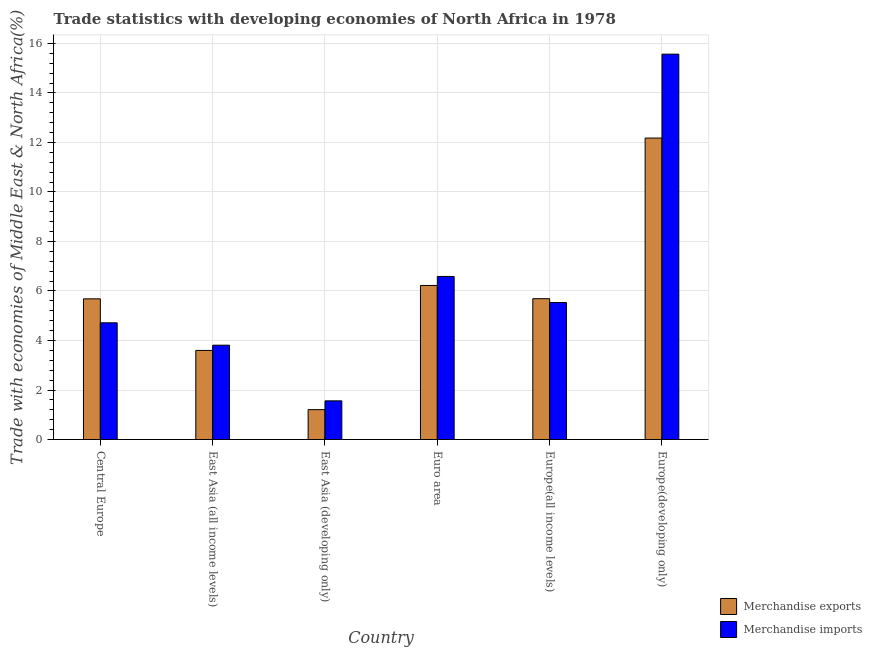Are the number of bars per tick equal to the number of legend labels?
Ensure brevity in your answer.  Yes. Are the number of bars on each tick of the X-axis equal?
Your response must be concise. Yes. What is the label of the 2nd group of bars from the left?
Keep it short and to the point. East Asia (all income levels). In how many cases, is the number of bars for a given country not equal to the number of legend labels?
Keep it short and to the point. 0. What is the merchandise exports in Europe(developing only)?
Your answer should be compact. 12.18. Across all countries, what is the maximum merchandise imports?
Provide a short and direct response. 15.57. Across all countries, what is the minimum merchandise imports?
Provide a short and direct response. 1.56. In which country was the merchandise exports maximum?
Ensure brevity in your answer.  Europe(developing only). In which country was the merchandise exports minimum?
Provide a succinct answer. East Asia (developing only). What is the total merchandise imports in the graph?
Make the answer very short. 37.78. What is the difference between the merchandise imports in East Asia (developing only) and that in Europe(developing only)?
Give a very brief answer. -14.01. What is the difference between the merchandise exports in Central Europe and the merchandise imports in Europe(developing only)?
Ensure brevity in your answer.  -9.89. What is the average merchandise exports per country?
Ensure brevity in your answer.  5.76. What is the difference between the merchandise exports and merchandise imports in East Asia (developing only)?
Offer a terse response. -0.35. In how many countries, is the merchandise imports greater than 0.8 %?
Your answer should be very brief. 6. What is the ratio of the merchandise imports in East Asia (developing only) to that in Euro area?
Your answer should be very brief. 0.24. Is the difference between the merchandise exports in Euro area and Europe(developing only) greater than the difference between the merchandise imports in Euro area and Europe(developing only)?
Provide a succinct answer. Yes. What is the difference between the highest and the second highest merchandise imports?
Your answer should be compact. 8.98. What is the difference between the highest and the lowest merchandise imports?
Your answer should be compact. 14.01. What does the 2nd bar from the right in East Asia (developing only) represents?
Offer a very short reply. Merchandise exports. How many bars are there?
Provide a short and direct response. 12. What is the difference between two consecutive major ticks on the Y-axis?
Keep it short and to the point. 2. Does the graph contain any zero values?
Your response must be concise. No. Where does the legend appear in the graph?
Provide a succinct answer. Bottom right. How many legend labels are there?
Keep it short and to the point. 2. How are the legend labels stacked?
Give a very brief answer. Vertical. What is the title of the graph?
Your answer should be compact. Trade statistics with developing economies of North Africa in 1978. What is the label or title of the Y-axis?
Give a very brief answer. Trade with economies of Middle East & North Africa(%). What is the Trade with economies of Middle East & North Africa(%) in Merchandise exports in Central Europe?
Your response must be concise. 5.68. What is the Trade with economies of Middle East & North Africa(%) of Merchandise imports in Central Europe?
Give a very brief answer. 4.71. What is the Trade with economies of Middle East & North Africa(%) in Merchandise exports in East Asia (all income levels)?
Keep it short and to the point. 3.6. What is the Trade with economies of Middle East & North Africa(%) in Merchandise imports in East Asia (all income levels)?
Offer a terse response. 3.81. What is the Trade with economies of Middle East & North Africa(%) of Merchandise exports in East Asia (developing only)?
Make the answer very short. 1.21. What is the Trade with economies of Middle East & North Africa(%) in Merchandise imports in East Asia (developing only)?
Your response must be concise. 1.56. What is the Trade with economies of Middle East & North Africa(%) of Merchandise exports in Euro area?
Provide a succinct answer. 6.22. What is the Trade with economies of Middle East & North Africa(%) in Merchandise imports in Euro area?
Provide a succinct answer. 6.59. What is the Trade with economies of Middle East & North Africa(%) of Merchandise exports in Europe(all income levels)?
Make the answer very short. 5.69. What is the Trade with economies of Middle East & North Africa(%) in Merchandise imports in Europe(all income levels)?
Offer a terse response. 5.54. What is the Trade with economies of Middle East & North Africa(%) in Merchandise exports in Europe(developing only)?
Give a very brief answer. 12.18. What is the Trade with economies of Middle East & North Africa(%) of Merchandise imports in Europe(developing only)?
Provide a succinct answer. 15.57. Across all countries, what is the maximum Trade with economies of Middle East & North Africa(%) of Merchandise exports?
Your answer should be very brief. 12.18. Across all countries, what is the maximum Trade with economies of Middle East & North Africa(%) in Merchandise imports?
Your response must be concise. 15.57. Across all countries, what is the minimum Trade with economies of Middle East & North Africa(%) of Merchandise exports?
Offer a very short reply. 1.21. Across all countries, what is the minimum Trade with economies of Middle East & North Africa(%) of Merchandise imports?
Provide a short and direct response. 1.56. What is the total Trade with economies of Middle East & North Africa(%) in Merchandise exports in the graph?
Keep it short and to the point. 34.58. What is the total Trade with economies of Middle East & North Africa(%) in Merchandise imports in the graph?
Provide a succinct answer. 37.78. What is the difference between the Trade with economies of Middle East & North Africa(%) of Merchandise exports in Central Europe and that in East Asia (all income levels)?
Provide a succinct answer. 2.08. What is the difference between the Trade with economies of Middle East & North Africa(%) in Merchandise imports in Central Europe and that in East Asia (all income levels)?
Offer a very short reply. 0.9. What is the difference between the Trade with economies of Middle East & North Africa(%) in Merchandise exports in Central Europe and that in East Asia (developing only)?
Your answer should be compact. 4.48. What is the difference between the Trade with economies of Middle East & North Africa(%) in Merchandise imports in Central Europe and that in East Asia (developing only)?
Make the answer very short. 3.15. What is the difference between the Trade with economies of Middle East & North Africa(%) of Merchandise exports in Central Europe and that in Euro area?
Offer a very short reply. -0.54. What is the difference between the Trade with economies of Middle East & North Africa(%) in Merchandise imports in Central Europe and that in Euro area?
Offer a very short reply. -1.87. What is the difference between the Trade with economies of Middle East & North Africa(%) of Merchandise exports in Central Europe and that in Europe(all income levels)?
Give a very brief answer. -0.01. What is the difference between the Trade with economies of Middle East & North Africa(%) of Merchandise imports in Central Europe and that in Europe(all income levels)?
Provide a short and direct response. -0.82. What is the difference between the Trade with economies of Middle East & North Africa(%) of Merchandise exports in Central Europe and that in Europe(developing only)?
Give a very brief answer. -6.5. What is the difference between the Trade with economies of Middle East & North Africa(%) of Merchandise imports in Central Europe and that in Europe(developing only)?
Offer a terse response. -10.85. What is the difference between the Trade with economies of Middle East & North Africa(%) of Merchandise exports in East Asia (all income levels) and that in East Asia (developing only)?
Your response must be concise. 2.39. What is the difference between the Trade with economies of Middle East & North Africa(%) in Merchandise imports in East Asia (all income levels) and that in East Asia (developing only)?
Offer a very short reply. 2.25. What is the difference between the Trade with economies of Middle East & North Africa(%) of Merchandise exports in East Asia (all income levels) and that in Euro area?
Give a very brief answer. -2.62. What is the difference between the Trade with economies of Middle East & North Africa(%) of Merchandise imports in East Asia (all income levels) and that in Euro area?
Keep it short and to the point. -2.78. What is the difference between the Trade with economies of Middle East & North Africa(%) in Merchandise exports in East Asia (all income levels) and that in Europe(all income levels)?
Make the answer very short. -2.09. What is the difference between the Trade with economies of Middle East & North Africa(%) in Merchandise imports in East Asia (all income levels) and that in Europe(all income levels)?
Offer a very short reply. -1.73. What is the difference between the Trade with economies of Middle East & North Africa(%) of Merchandise exports in East Asia (all income levels) and that in Europe(developing only)?
Provide a short and direct response. -8.58. What is the difference between the Trade with economies of Middle East & North Africa(%) in Merchandise imports in East Asia (all income levels) and that in Europe(developing only)?
Ensure brevity in your answer.  -11.76. What is the difference between the Trade with economies of Middle East & North Africa(%) of Merchandise exports in East Asia (developing only) and that in Euro area?
Your response must be concise. -5.02. What is the difference between the Trade with economies of Middle East & North Africa(%) in Merchandise imports in East Asia (developing only) and that in Euro area?
Give a very brief answer. -5.03. What is the difference between the Trade with economies of Middle East & North Africa(%) in Merchandise exports in East Asia (developing only) and that in Europe(all income levels)?
Provide a succinct answer. -4.48. What is the difference between the Trade with economies of Middle East & North Africa(%) in Merchandise imports in East Asia (developing only) and that in Europe(all income levels)?
Keep it short and to the point. -3.97. What is the difference between the Trade with economies of Middle East & North Africa(%) in Merchandise exports in East Asia (developing only) and that in Europe(developing only)?
Provide a succinct answer. -10.97. What is the difference between the Trade with economies of Middle East & North Africa(%) in Merchandise imports in East Asia (developing only) and that in Europe(developing only)?
Your response must be concise. -14.01. What is the difference between the Trade with economies of Middle East & North Africa(%) of Merchandise exports in Euro area and that in Europe(all income levels)?
Provide a short and direct response. 0.53. What is the difference between the Trade with economies of Middle East & North Africa(%) in Merchandise imports in Euro area and that in Europe(all income levels)?
Provide a short and direct response. 1.05. What is the difference between the Trade with economies of Middle East & North Africa(%) in Merchandise exports in Euro area and that in Europe(developing only)?
Your answer should be compact. -5.96. What is the difference between the Trade with economies of Middle East & North Africa(%) of Merchandise imports in Euro area and that in Europe(developing only)?
Ensure brevity in your answer.  -8.98. What is the difference between the Trade with economies of Middle East & North Africa(%) in Merchandise exports in Europe(all income levels) and that in Europe(developing only)?
Your response must be concise. -6.49. What is the difference between the Trade with economies of Middle East & North Africa(%) in Merchandise imports in Europe(all income levels) and that in Europe(developing only)?
Offer a terse response. -10.03. What is the difference between the Trade with economies of Middle East & North Africa(%) in Merchandise exports in Central Europe and the Trade with economies of Middle East & North Africa(%) in Merchandise imports in East Asia (all income levels)?
Offer a terse response. 1.87. What is the difference between the Trade with economies of Middle East & North Africa(%) of Merchandise exports in Central Europe and the Trade with economies of Middle East & North Africa(%) of Merchandise imports in East Asia (developing only)?
Offer a very short reply. 4.12. What is the difference between the Trade with economies of Middle East & North Africa(%) in Merchandise exports in Central Europe and the Trade with economies of Middle East & North Africa(%) in Merchandise imports in Euro area?
Give a very brief answer. -0.9. What is the difference between the Trade with economies of Middle East & North Africa(%) of Merchandise exports in Central Europe and the Trade with economies of Middle East & North Africa(%) of Merchandise imports in Europe(all income levels)?
Keep it short and to the point. 0.15. What is the difference between the Trade with economies of Middle East & North Africa(%) in Merchandise exports in Central Europe and the Trade with economies of Middle East & North Africa(%) in Merchandise imports in Europe(developing only)?
Your answer should be very brief. -9.89. What is the difference between the Trade with economies of Middle East & North Africa(%) of Merchandise exports in East Asia (all income levels) and the Trade with economies of Middle East & North Africa(%) of Merchandise imports in East Asia (developing only)?
Provide a succinct answer. 2.04. What is the difference between the Trade with economies of Middle East & North Africa(%) in Merchandise exports in East Asia (all income levels) and the Trade with economies of Middle East & North Africa(%) in Merchandise imports in Euro area?
Give a very brief answer. -2.99. What is the difference between the Trade with economies of Middle East & North Africa(%) in Merchandise exports in East Asia (all income levels) and the Trade with economies of Middle East & North Africa(%) in Merchandise imports in Europe(all income levels)?
Ensure brevity in your answer.  -1.94. What is the difference between the Trade with economies of Middle East & North Africa(%) of Merchandise exports in East Asia (all income levels) and the Trade with economies of Middle East & North Africa(%) of Merchandise imports in Europe(developing only)?
Keep it short and to the point. -11.97. What is the difference between the Trade with economies of Middle East & North Africa(%) of Merchandise exports in East Asia (developing only) and the Trade with economies of Middle East & North Africa(%) of Merchandise imports in Euro area?
Offer a terse response. -5.38. What is the difference between the Trade with economies of Middle East & North Africa(%) in Merchandise exports in East Asia (developing only) and the Trade with economies of Middle East & North Africa(%) in Merchandise imports in Europe(all income levels)?
Your answer should be very brief. -4.33. What is the difference between the Trade with economies of Middle East & North Africa(%) in Merchandise exports in East Asia (developing only) and the Trade with economies of Middle East & North Africa(%) in Merchandise imports in Europe(developing only)?
Ensure brevity in your answer.  -14.36. What is the difference between the Trade with economies of Middle East & North Africa(%) in Merchandise exports in Euro area and the Trade with economies of Middle East & North Africa(%) in Merchandise imports in Europe(all income levels)?
Make the answer very short. 0.69. What is the difference between the Trade with economies of Middle East & North Africa(%) in Merchandise exports in Euro area and the Trade with economies of Middle East & North Africa(%) in Merchandise imports in Europe(developing only)?
Offer a very short reply. -9.34. What is the difference between the Trade with economies of Middle East & North Africa(%) of Merchandise exports in Europe(all income levels) and the Trade with economies of Middle East & North Africa(%) of Merchandise imports in Europe(developing only)?
Keep it short and to the point. -9.88. What is the average Trade with economies of Middle East & North Africa(%) of Merchandise exports per country?
Give a very brief answer. 5.76. What is the average Trade with economies of Middle East & North Africa(%) in Merchandise imports per country?
Your answer should be compact. 6.3. What is the difference between the Trade with economies of Middle East & North Africa(%) of Merchandise exports and Trade with economies of Middle East & North Africa(%) of Merchandise imports in Central Europe?
Make the answer very short. 0.97. What is the difference between the Trade with economies of Middle East & North Africa(%) in Merchandise exports and Trade with economies of Middle East & North Africa(%) in Merchandise imports in East Asia (all income levels)?
Give a very brief answer. -0.21. What is the difference between the Trade with economies of Middle East & North Africa(%) of Merchandise exports and Trade with economies of Middle East & North Africa(%) of Merchandise imports in East Asia (developing only)?
Provide a succinct answer. -0.35. What is the difference between the Trade with economies of Middle East & North Africa(%) in Merchandise exports and Trade with economies of Middle East & North Africa(%) in Merchandise imports in Euro area?
Offer a terse response. -0.36. What is the difference between the Trade with economies of Middle East & North Africa(%) of Merchandise exports and Trade with economies of Middle East & North Africa(%) of Merchandise imports in Europe(all income levels)?
Offer a terse response. 0.15. What is the difference between the Trade with economies of Middle East & North Africa(%) of Merchandise exports and Trade with economies of Middle East & North Africa(%) of Merchandise imports in Europe(developing only)?
Offer a very short reply. -3.39. What is the ratio of the Trade with economies of Middle East & North Africa(%) in Merchandise exports in Central Europe to that in East Asia (all income levels)?
Give a very brief answer. 1.58. What is the ratio of the Trade with economies of Middle East & North Africa(%) of Merchandise imports in Central Europe to that in East Asia (all income levels)?
Provide a succinct answer. 1.24. What is the ratio of the Trade with economies of Middle East & North Africa(%) of Merchandise exports in Central Europe to that in East Asia (developing only)?
Ensure brevity in your answer.  4.71. What is the ratio of the Trade with economies of Middle East & North Africa(%) of Merchandise imports in Central Europe to that in East Asia (developing only)?
Keep it short and to the point. 3.02. What is the ratio of the Trade with economies of Middle East & North Africa(%) in Merchandise exports in Central Europe to that in Euro area?
Make the answer very short. 0.91. What is the ratio of the Trade with economies of Middle East & North Africa(%) in Merchandise imports in Central Europe to that in Euro area?
Give a very brief answer. 0.72. What is the ratio of the Trade with economies of Middle East & North Africa(%) in Merchandise imports in Central Europe to that in Europe(all income levels)?
Provide a succinct answer. 0.85. What is the ratio of the Trade with economies of Middle East & North Africa(%) in Merchandise exports in Central Europe to that in Europe(developing only)?
Give a very brief answer. 0.47. What is the ratio of the Trade with economies of Middle East & North Africa(%) of Merchandise imports in Central Europe to that in Europe(developing only)?
Keep it short and to the point. 0.3. What is the ratio of the Trade with economies of Middle East & North Africa(%) in Merchandise exports in East Asia (all income levels) to that in East Asia (developing only)?
Your answer should be compact. 2.98. What is the ratio of the Trade with economies of Middle East & North Africa(%) of Merchandise imports in East Asia (all income levels) to that in East Asia (developing only)?
Ensure brevity in your answer.  2.44. What is the ratio of the Trade with economies of Middle East & North Africa(%) of Merchandise exports in East Asia (all income levels) to that in Euro area?
Give a very brief answer. 0.58. What is the ratio of the Trade with economies of Middle East & North Africa(%) in Merchandise imports in East Asia (all income levels) to that in Euro area?
Keep it short and to the point. 0.58. What is the ratio of the Trade with economies of Middle East & North Africa(%) of Merchandise exports in East Asia (all income levels) to that in Europe(all income levels)?
Your answer should be very brief. 0.63. What is the ratio of the Trade with economies of Middle East & North Africa(%) in Merchandise imports in East Asia (all income levels) to that in Europe(all income levels)?
Give a very brief answer. 0.69. What is the ratio of the Trade with economies of Middle East & North Africa(%) of Merchandise exports in East Asia (all income levels) to that in Europe(developing only)?
Your response must be concise. 0.3. What is the ratio of the Trade with economies of Middle East & North Africa(%) of Merchandise imports in East Asia (all income levels) to that in Europe(developing only)?
Give a very brief answer. 0.24. What is the ratio of the Trade with economies of Middle East & North Africa(%) in Merchandise exports in East Asia (developing only) to that in Euro area?
Your answer should be very brief. 0.19. What is the ratio of the Trade with economies of Middle East & North Africa(%) in Merchandise imports in East Asia (developing only) to that in Euro area?
Offer a terse response. 0.24. What is the ratio of the Trade with economies of Middle East & North Africa(%) in Merchandise exports in East Asia (developing only) to that in Europe(all income levels)?
Your response must be concise. 0.21. What is the ratio of the Trade with economies of Middle East & North Africa(%) of Merchandise imports in East Asia (developing only) to that in Europe(all income levels)?
Your answer should be compact. 0.28. What is the ratio of the Trade with economies of Middle East & North Africa(%) in Merchandise exports in East Asia (developing only) to that in Europe(developing only)?
Make the answer very short. 0.1. What is the ratio of the Trade with economies of Middle East & North Africa(%) in Merchandise imports in East Asia (developing only) to that in Europe(developing only)?
Offer a terse response. 0.1. What is the ratio of the Trade with economies of Middle East & North Africa(%) in Merchandise exports in Euro area to that in Europe(all income levels)?
Your response must be concise. 1.09. What is the ratio of the Trade with economies of Middle East & North Africa(%) in Merchandise imports in Euro area to that in Europe(all income levels)?
Offer a terse response. 1.19. What is the ratio of the Trade with economies of Middle East & North Africa(%) of Merchandise exports in Euro area to that in Europe(developing only)?
Give a very brief answer. 0.51. What is the ratio of the Trade with economies of Middle East & North Africa(%) in Merchandise imports in Euro area to that in Europe(developing only)?
Make the answer very short. 0.42. What is the ratio of the Trade with economies of Middle East & North Africa(%) in Merchandise exports in Europe(all income levels) to that in Europe(developing only)?
Offer a very short reply. 0.47. What is the ratio of the Trade with economies of Middle East & North Africa(%) of Merchandise imports in Europe(all income levels) to that in Europe(developing only)?
Give a very brief answer. 0.36. What is the difference between the highest and the second highest Trade with economies of Middle East & North Africa(%) in Merchandise exports?
Give a very brief answer. 5.96. What is the difference between the highest and the second highest Trade with economies of Middle East & North Africa(%) of Merchandise imports?
Provide a short and direct response. 8.98. What is the difference between the highest and the lowest Trade with economies of Middle East & North Africa(%) of Merchandise exports?
Offer a terse response. 10.97. What is the difference between the highest and the lowest Trade with economies of Middle East & North Africa(%) of Merchandise imports?
Your answer should be very brief. 14.01. 